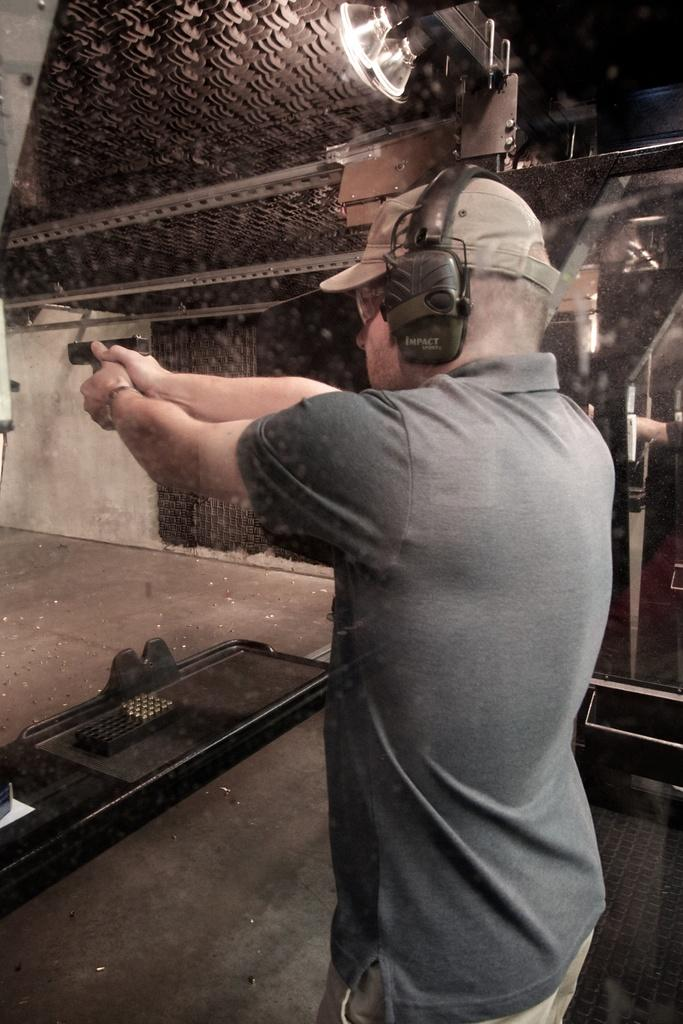What is the person in the image doing? The person is standing in the image and holding a gun in their hand. What accessories is the person wearing? The person is wearing a watch, headsets, goggles, and a cap. What is on the floor in the image? There is a tray on the floor in the image. What type of care is the person providing to the scissors in the image? There are no scissors present in the image, so no care is being provided to them. 